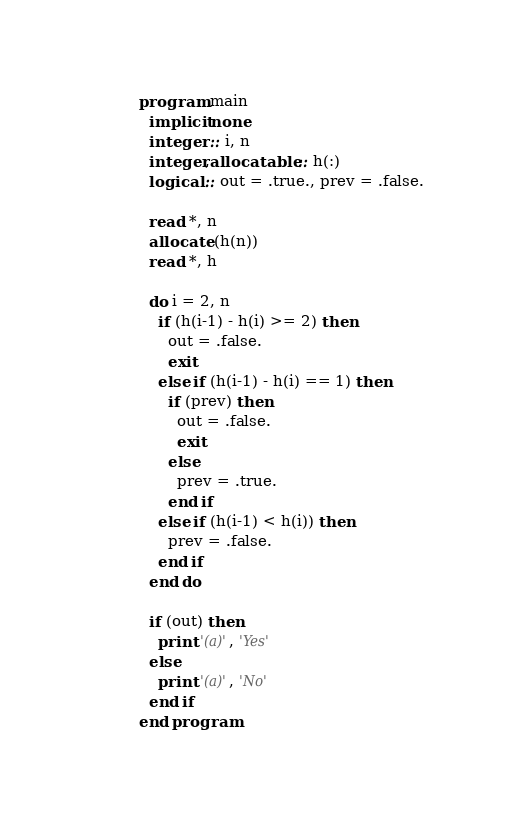<code> <loc_0><loc_0><loc_500><loc_500><_FORTRAN_>program main
  implicit none
  integer :: i, n
  integer,allocatable :: h(:)
  logical :: out = .true., prev = .false.

  read *, n
  allocate (h(n))
  read *, h

  do i = 2, n
    if (h(i-1) - h(i) >= 2) then
      out = .false.
      exit
    else if (h(i-1) - h(i) == 1) then
      if (prev) then
        out = .false.
        exit
      else
        prev = .true.
      end if
    else if (h(i-1) < h(i)) then
      prev = .false.
    end if
  end do

  if (out) then
    print '(a)', 'Yes'
  else
    print '(a)', 'No'
  end if
end program
</code> 